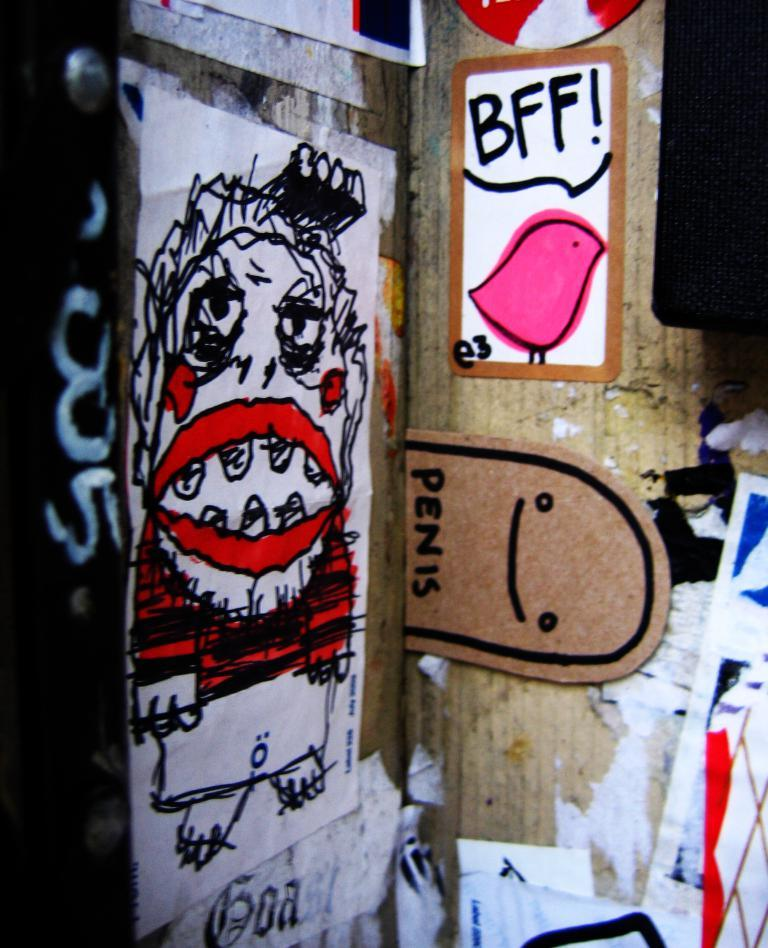What can be seen on the papers in the image? There are drawings on papers in the image. Where are the papers with drawings located? The papers with drawings are pasted on a wall. What other object is pasted on the wall in the image? There is a cardboard sheet in the image, which is also pasted on the wall. What type of vase is present on the committee in the image? There is no vase or committee present in the image; it only features drawings on papers and a cardboard sheet pasted on a wall. 